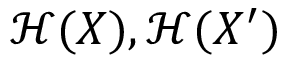<formula> <loc_0><loc_0><loc_500><loc_500>{ \mathcal { H } } ( X ) , { \mathcal { H } } ( X ^ { \prime } )</formula> 